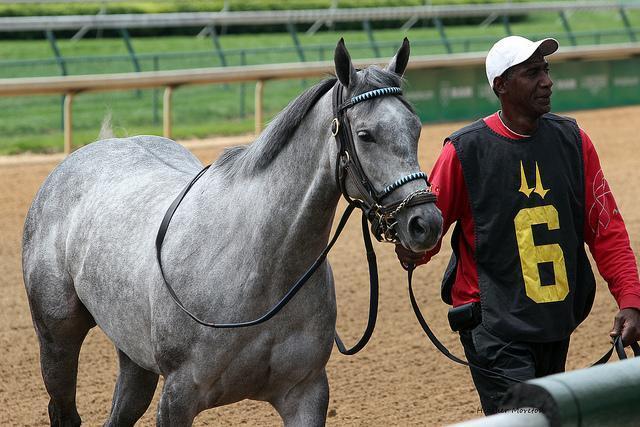Is this affirmation: "The horse is in front of the person." correct?
Answer yes or no. No. 